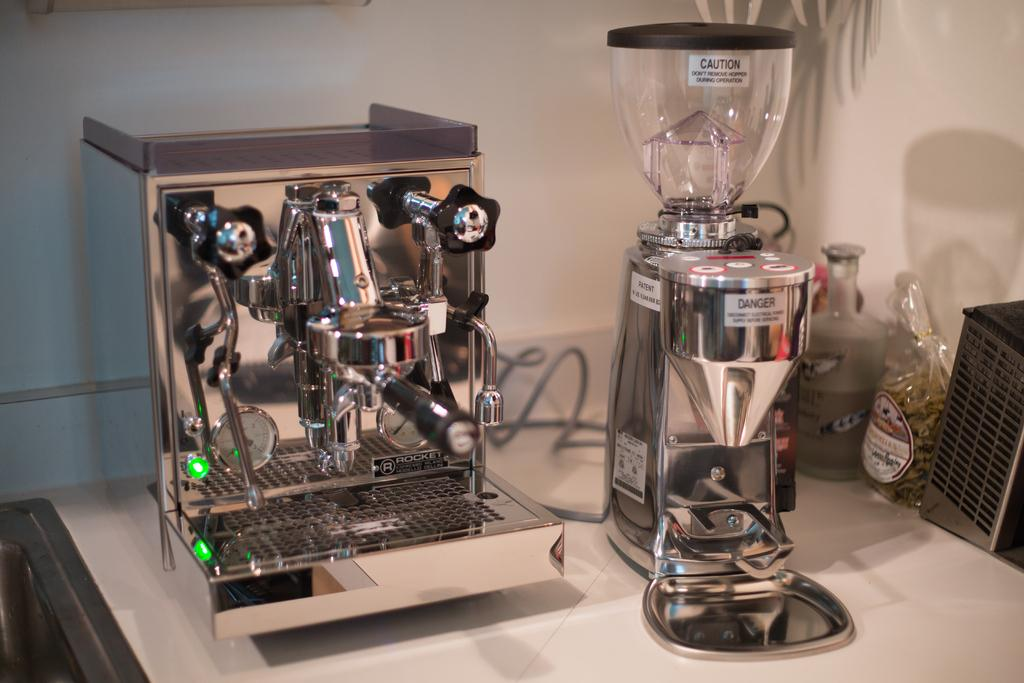<image>
Write a terse but informative summary of the picture. A coffee bean grinder, blender, and mixer on a table, all with "Danger" labels on them. 